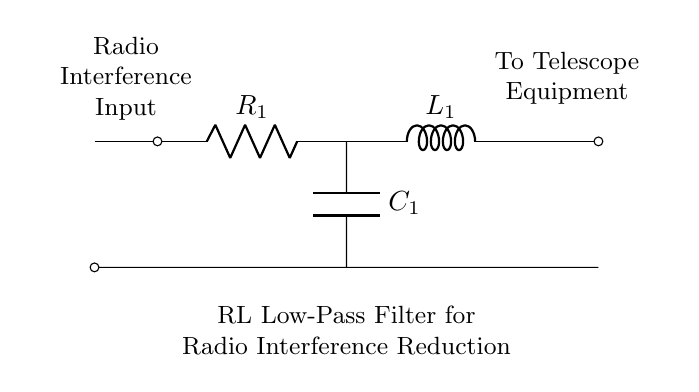What is the first component in the circuit? The first component encountered when following the connections from left to right is a resistor, labeled R_1.
Answer: resistor What type of filter is implemented in this circuit? The circuit diagram indicates an RL low-pass filter configuration, designed to pass low-frequency signals while attenuating high-frequency noise, which is suitable for reducing radio interference.
Answer: low-pass filter What does the inductor L_1 do in this circuit? The inductor L_1 opposes changes in current and contributes to the low-pass filtering effect, helping to smooth out high-frequency interference in the signal going to the telescope equipment.
Answer: smoothes current How is the capacitor C_1 connected in this circuit? The capacitor C_1 is connected in parallel with the output of the resistor R_1 and inductor L_1. This parallel arrangement assists in diverting high-frequency signals to ground, further enhancing the filtering effect.
Answer: parallel What is the function of the resistor R_1 in the filtering circuit? The resistor R_1 limits the current flowing through the circuit and, in conjunction with the inductor L_1, helps to filter out radio interference by creating a voltage drop that is frequency-dependent.
Answer: limits current Which component is directly labeled as the "Radio Interference Input"? The input for radio interference is designated at the position of the circuit where the resistor R_1 connects, indicating where the interference signals enter the filtering network.
Answer: R_1 Where does the filtered signal go in the circuit? The processed signal, after passing through the filtering components, exits the circuit labeled as "To Telescope Equipment," indicating the destination for the reduced interference signal.
Answer: telescope equipment 